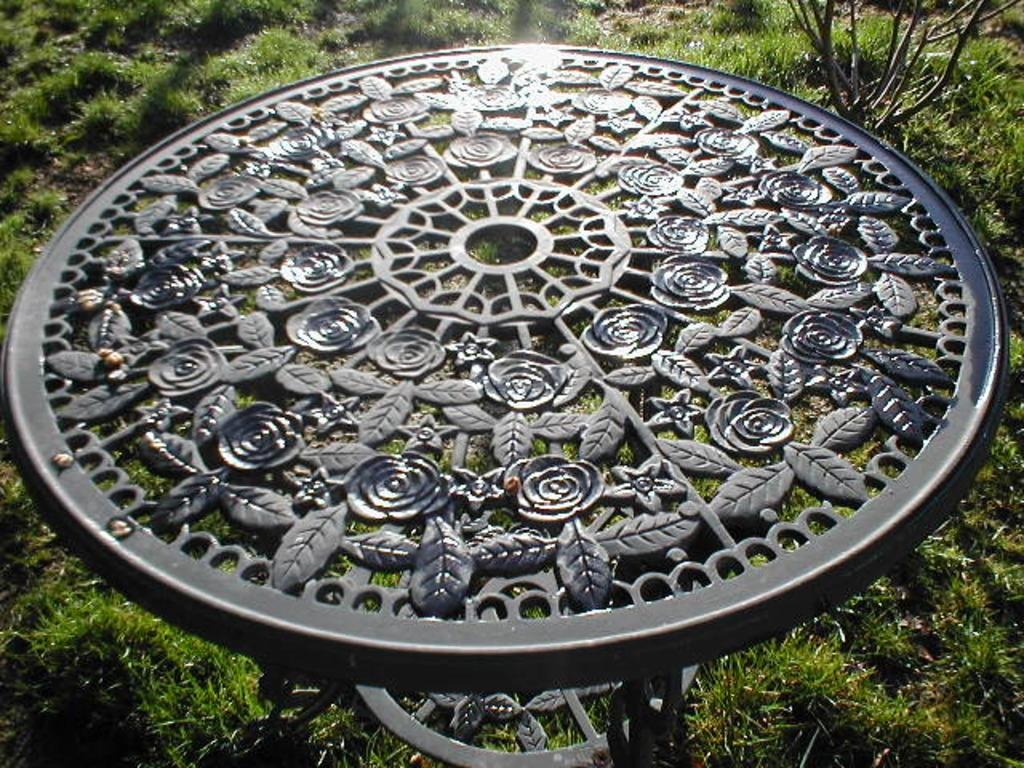What is the main object in the center of the image? There is a sundial present in the center of the image. What can be seen in the background of the image? There is a plant in the background of the image. What type of vegetation covers the ground in the image? The ground is covered with grass at the bottom of the image. What type of jam is spread on the rail in the image? There is no jam or rail present in the image; it features a sundial and a plant in the background. What type of oatmeal is being prepared in the image? There is no oatmeal or preparation activity present in the image; it features a sundial and a plant in the background. 